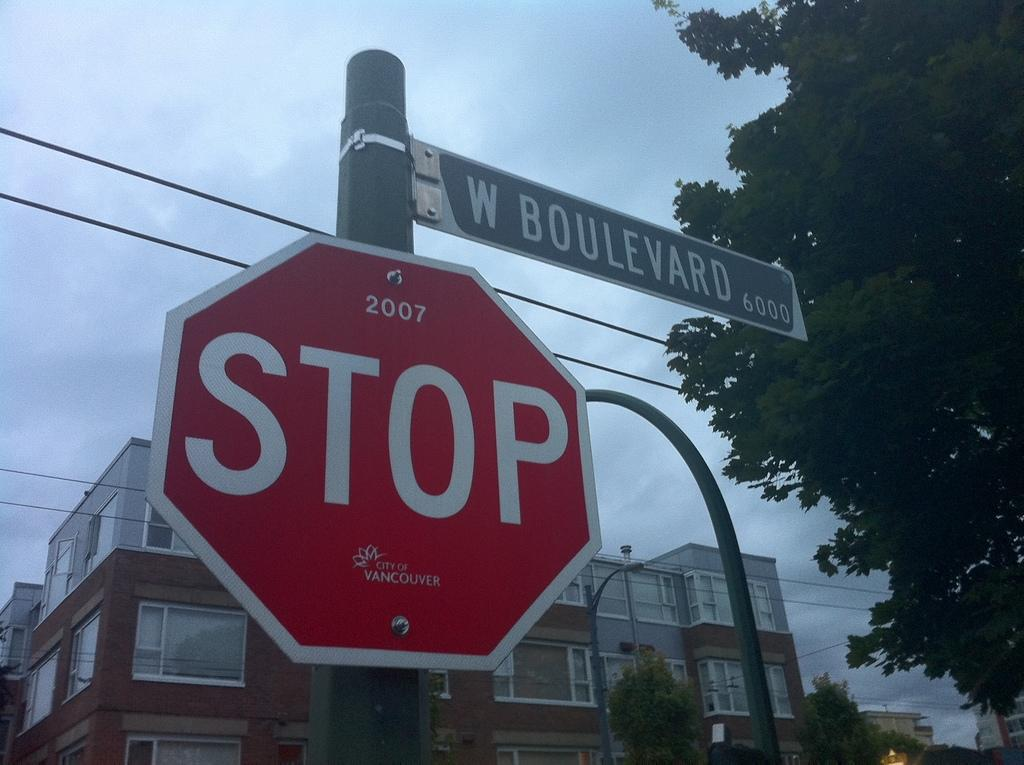<image>
Create a compact narrative representing the image presented. The red sign shown hands beside W Bouvevard sign. 